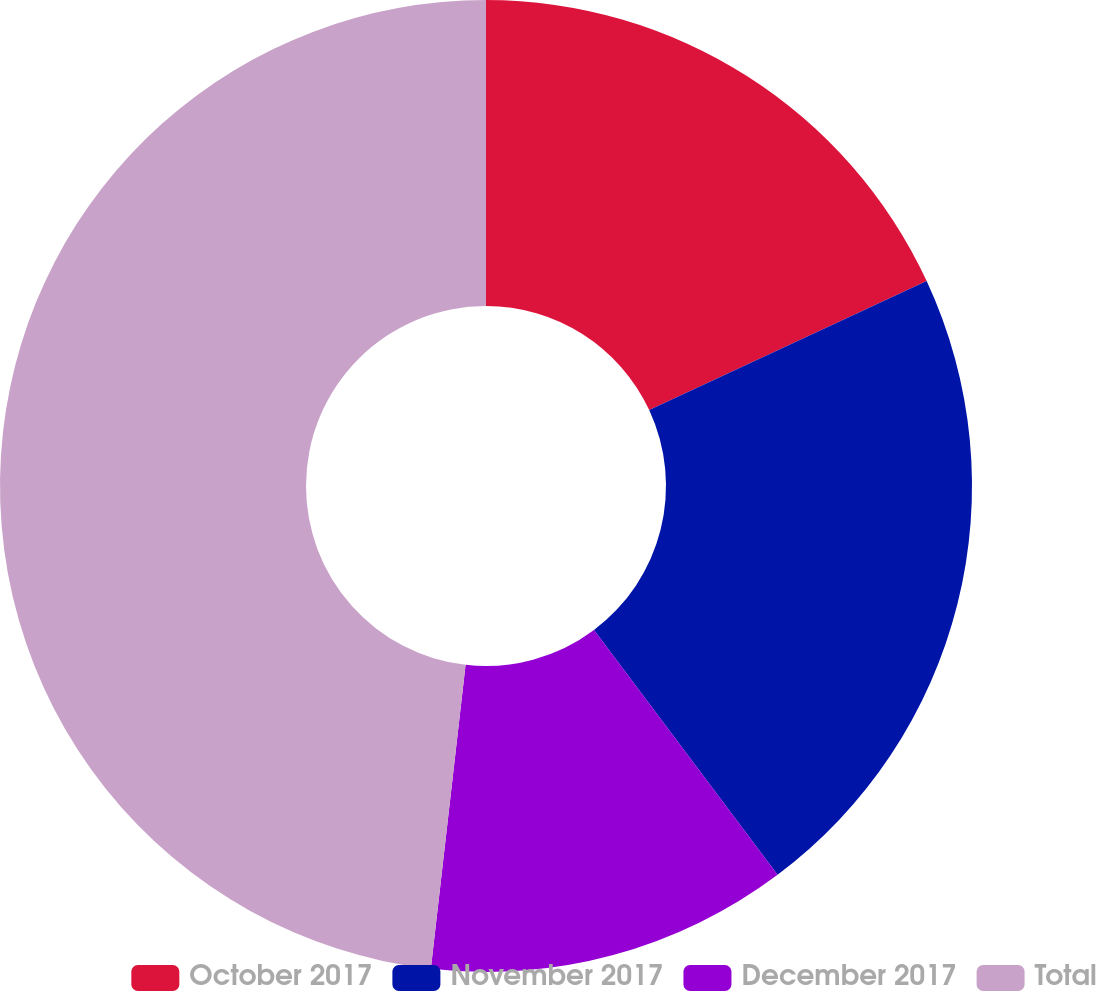Convert chart to OTSL. <chart><loc_0><loc_0><loc_500><loc_500><pie_chart><fcel>October 2017<fcel>November 2017<fcel>December 2017<fcel>Total<nl><fcel>18.07%<fcel>21.69%<fcel>12.05%<fcel>48.19%<nl></chart> 